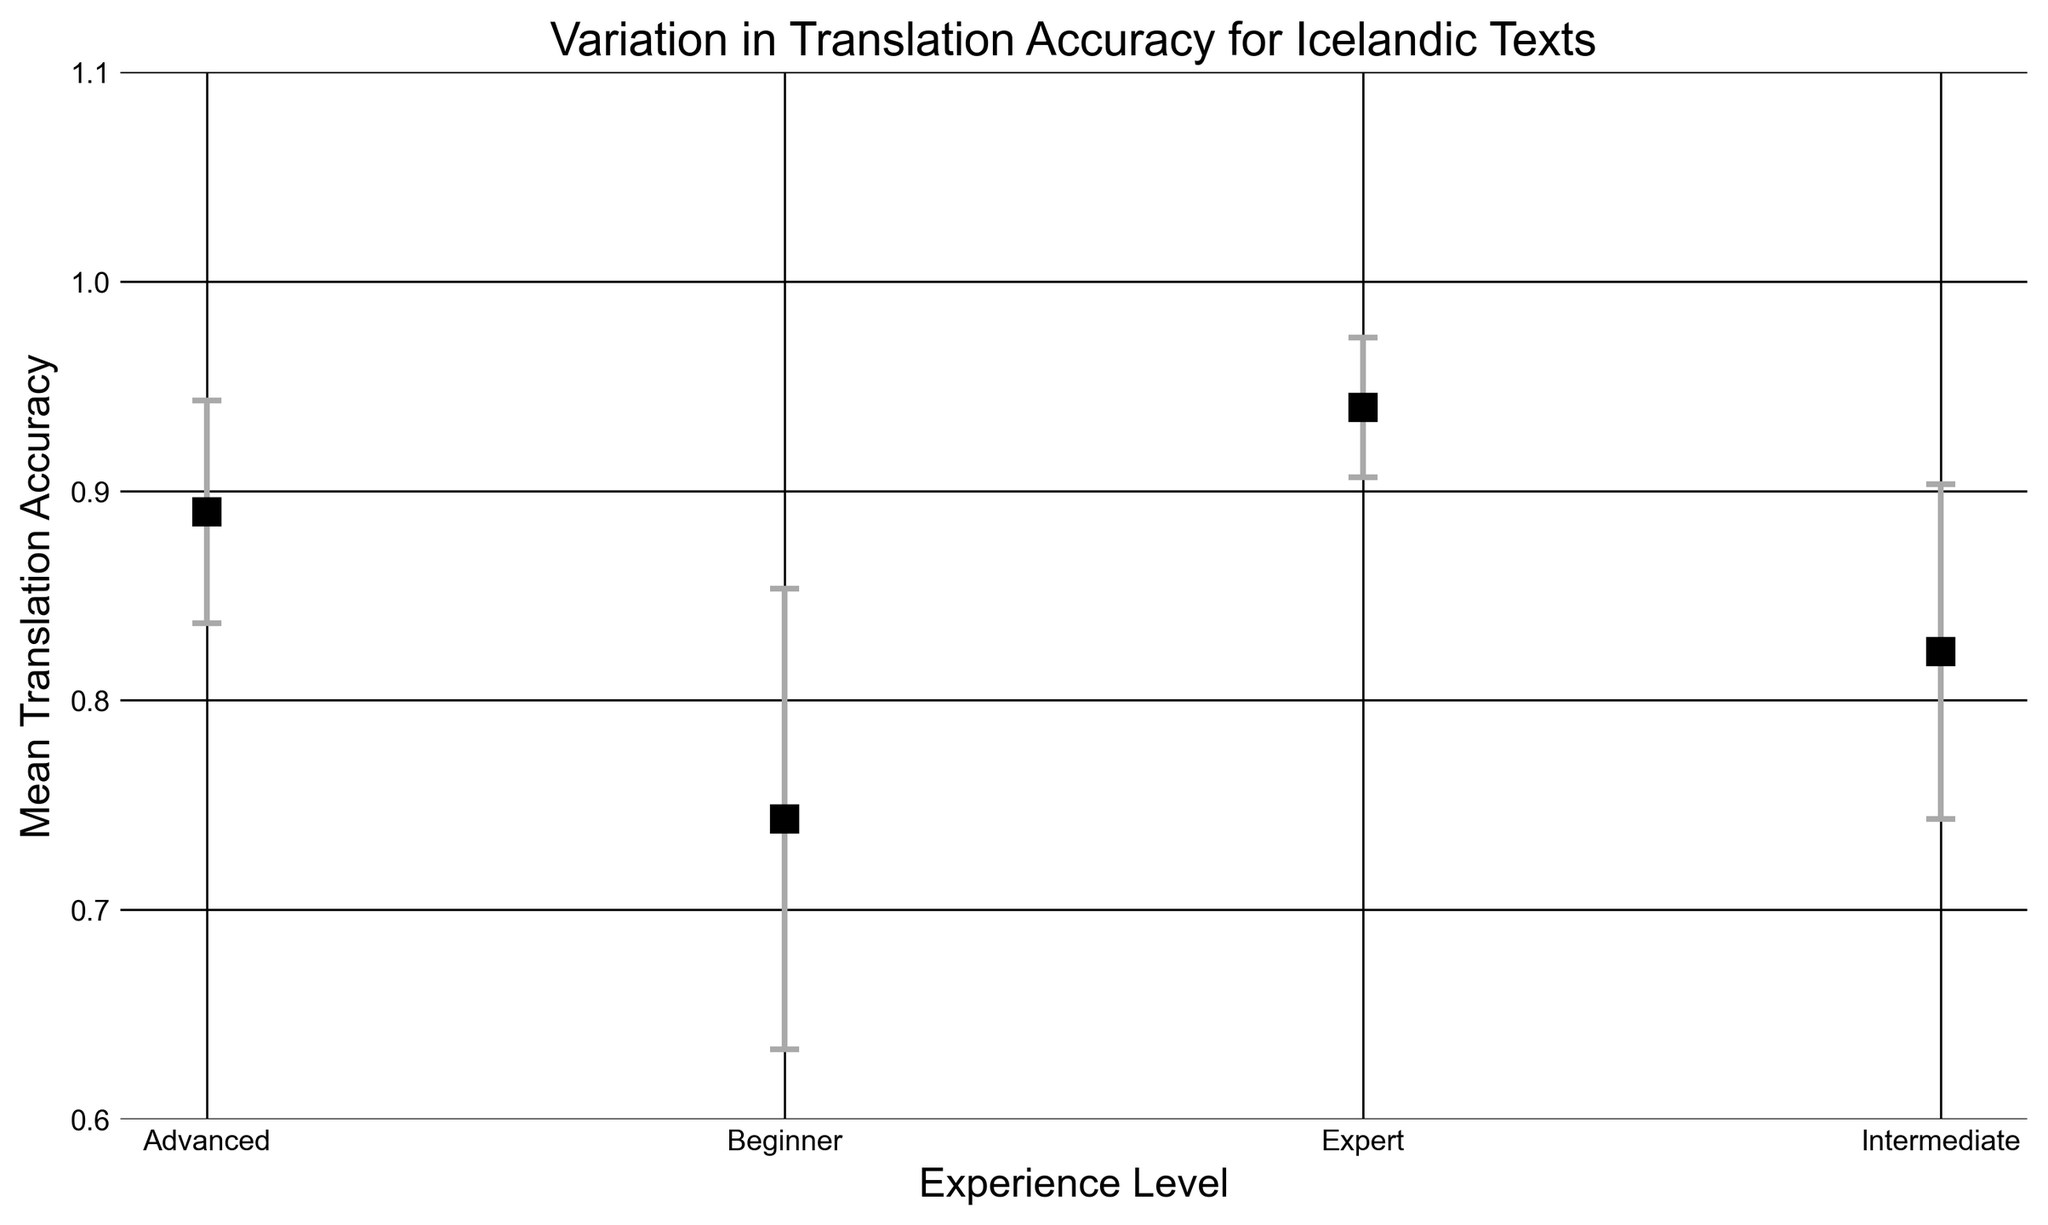What is the mean translation accuracy for intermediate translators? Refer to the y-axis value for intermediate level translators, which is plotted along the x-axis labeled "Experience Level". The mean accuracy for the intermediate level is marked with an 's' marker.
Answer: 0.82 Which experience level has the highest mean translation accuracy? Look at the markers on the plot for each experience level and observe the corresponding mean accuracy values on the y-axis. The experience level that has the highest y-value represents the highest mean translation accuracy.
Answer: Expert What is the range of the error bars for advanced translators? Observe the marker for the advanced level and the length of the error bars extending above and below it. The error bars indicate the standard deviation.
Answer: 0.05 By how much does the mean translation accuracy increase from beginner to expert translators? Compute the difference in mean translation accuracy between beginner and expert translators by subtracting the beginner mean accuracy from the expert mean accuracy. Check the respective y-axis values for these two experience levels.
Answer: 0.93 - 0.75 = 0.18 What is the mean translation accuracy for all translators combined? Calculate the average of the mean accuracies for all four experience levels (Beginner, Intermediate, Advanced, Expert). (0.75 + 0.82 + 0.88 + 0.93) / 4 = 3.38/4 = 0.845
Answer: 0.845 What is the mean translation accuracy difference between intermediate and advanced translators? Determine the mean translation accuracies for both intermediate and advanced levels, then subtract the intermediate mean accuracy from the advanced mean accuracy. 0.88 - 0.82
Answer: 0.06 Which experience level has the smallest standard deviation in translation accuracy? Find the markers corresponding to each experience level and check the size of their error bars. The experience level with the smallest error bars denotes the smallest standard deviation.
Answer: Expert What is the mean translation accuracy for beginner translators? Check the plotted marker for beginner level on the x-axis and observe its corresponding value on the y-axis.
Answer: 0.75 Do the advanced translators have a higher mean translation accuracy than the intermediate translators? Compare the y-axis values of the markers for advanced and intermediate translators along the x-axis labeled "Experience Level". Verify if the advanced marker is higher than the intermediate marker.
Answer: Yes What is the visual difference between the markers for beginner and expert translators? Observe the markers on the plot for beginner and expert levels: marker type, size, and position along the y-axis indicating their accuracy values, along with the length of error bars.
Answer: Beginner markers are significantly lower and have longer error bars than expert markers 